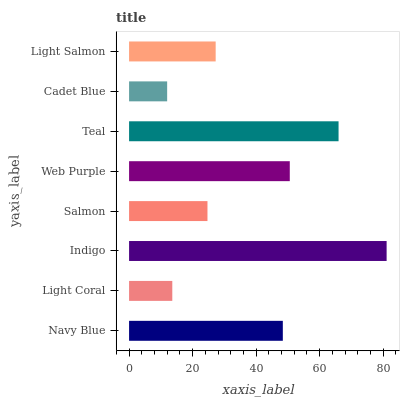Is Cadet Blue the minimum?
Answer yes or no. Yes. Is Indigo the maximum?
Answer yes or no. Yes. Is Light Coral the minimum?
Answer yes or no. No. Is Light Coral the maximum?
Answer yes or no. No. Is Navy Blue greater than Light Coral?
Answer yes or no. Yes. Is Light Coral less than Navy Blue?
Answer yes or no. Yes. Is Light Coral greater than Navy Blue?
Answer yes or no. No. Is Navy Blue less than Light Coral?
Answer yes or no. No. Is Navy Blue the high median?
Answer yes or no. Yes. Is Light Salmon the low median?
Answer yes or no. Yes. Is Web Purple the high median?
Answer yes or no. No. Is Web Purple the low median?
Answer yes or no. No. 